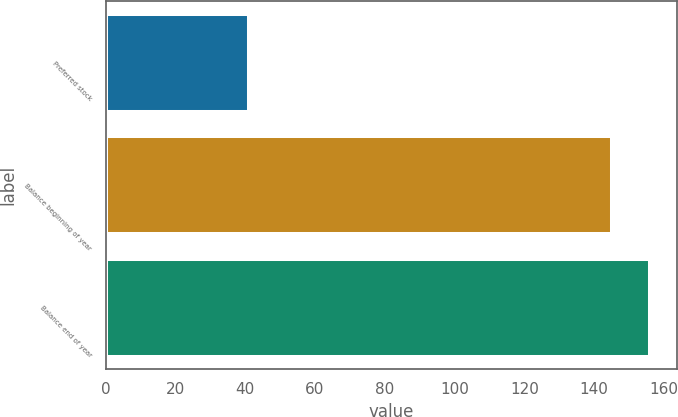Convert chart to OTSL. <chart><loc_0><loc_0><loc_500><loc_500><bar_chart><fcel>Preferred stock<fcel>Balance beginning of year<fcel>Balance end of year<nl><fcel>41<fcel>145<fcel>155.9<nl></chart> 